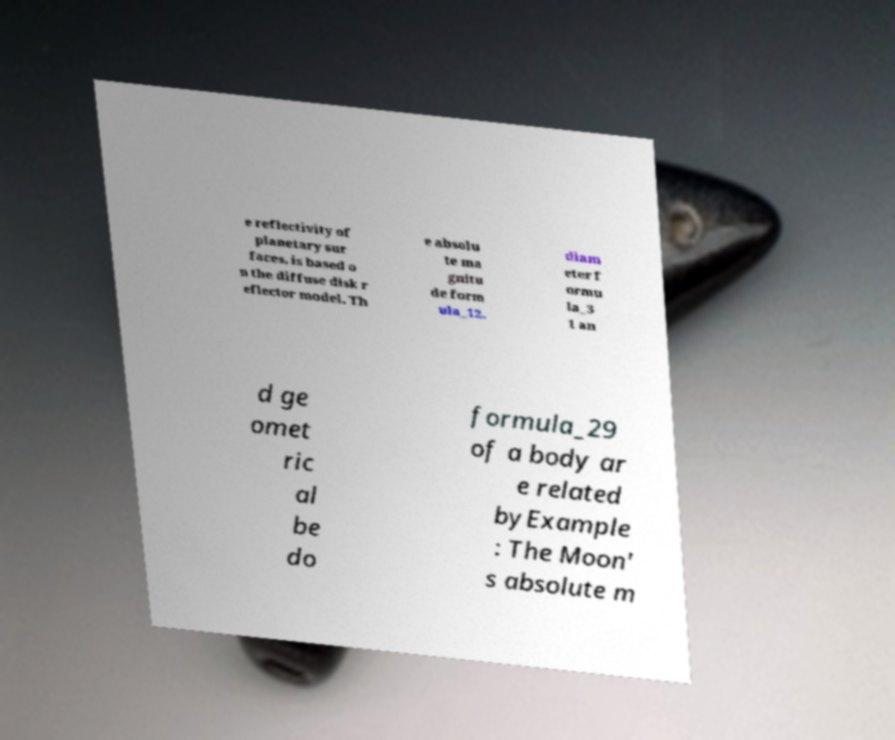I need the written content from this picture converted into text. Can you do that? e reflectivity of planetary sur faces, is based o n the diffuse disk r eflector model. Th e absolu te ma gnitu de form ula_12, diam eter f ormu la_3 1 an d ge omet ric al be do formula_29 of a body ar e related byExample : The Moon' s absolute m 